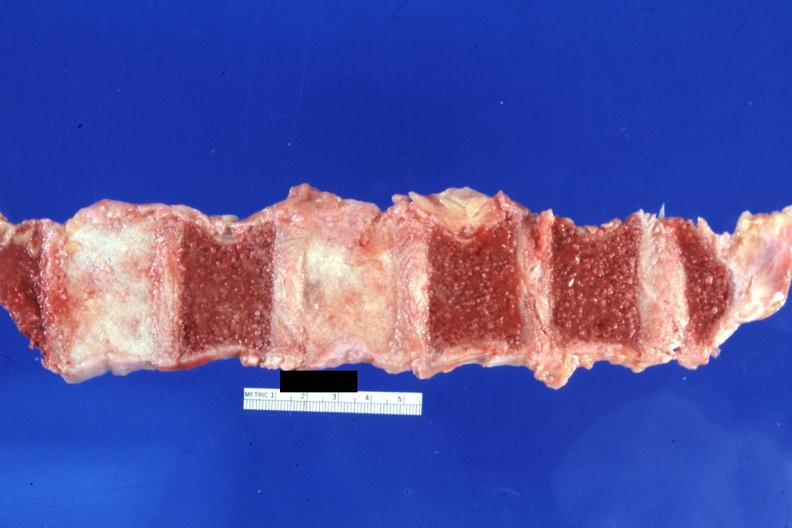s cut surface typical ivory vertebra do not have history at this time diagnosis assumed?
Answer the question using a single word or phrase. Yes 